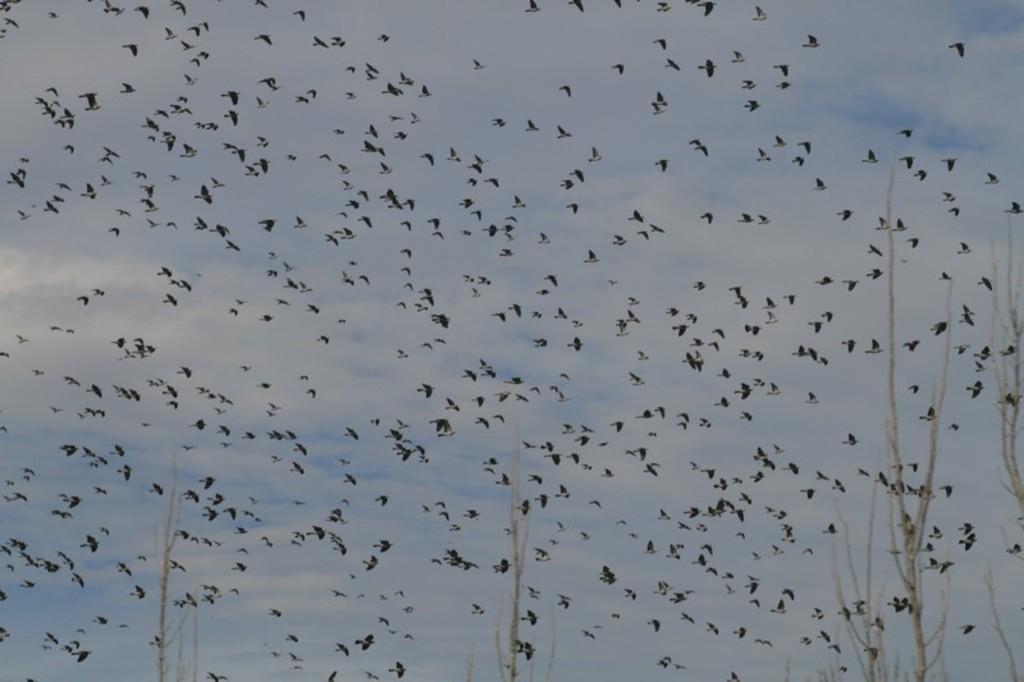Please provide a concise description of this image. In this image, we can see birds flying in the sky and we can see trees. 